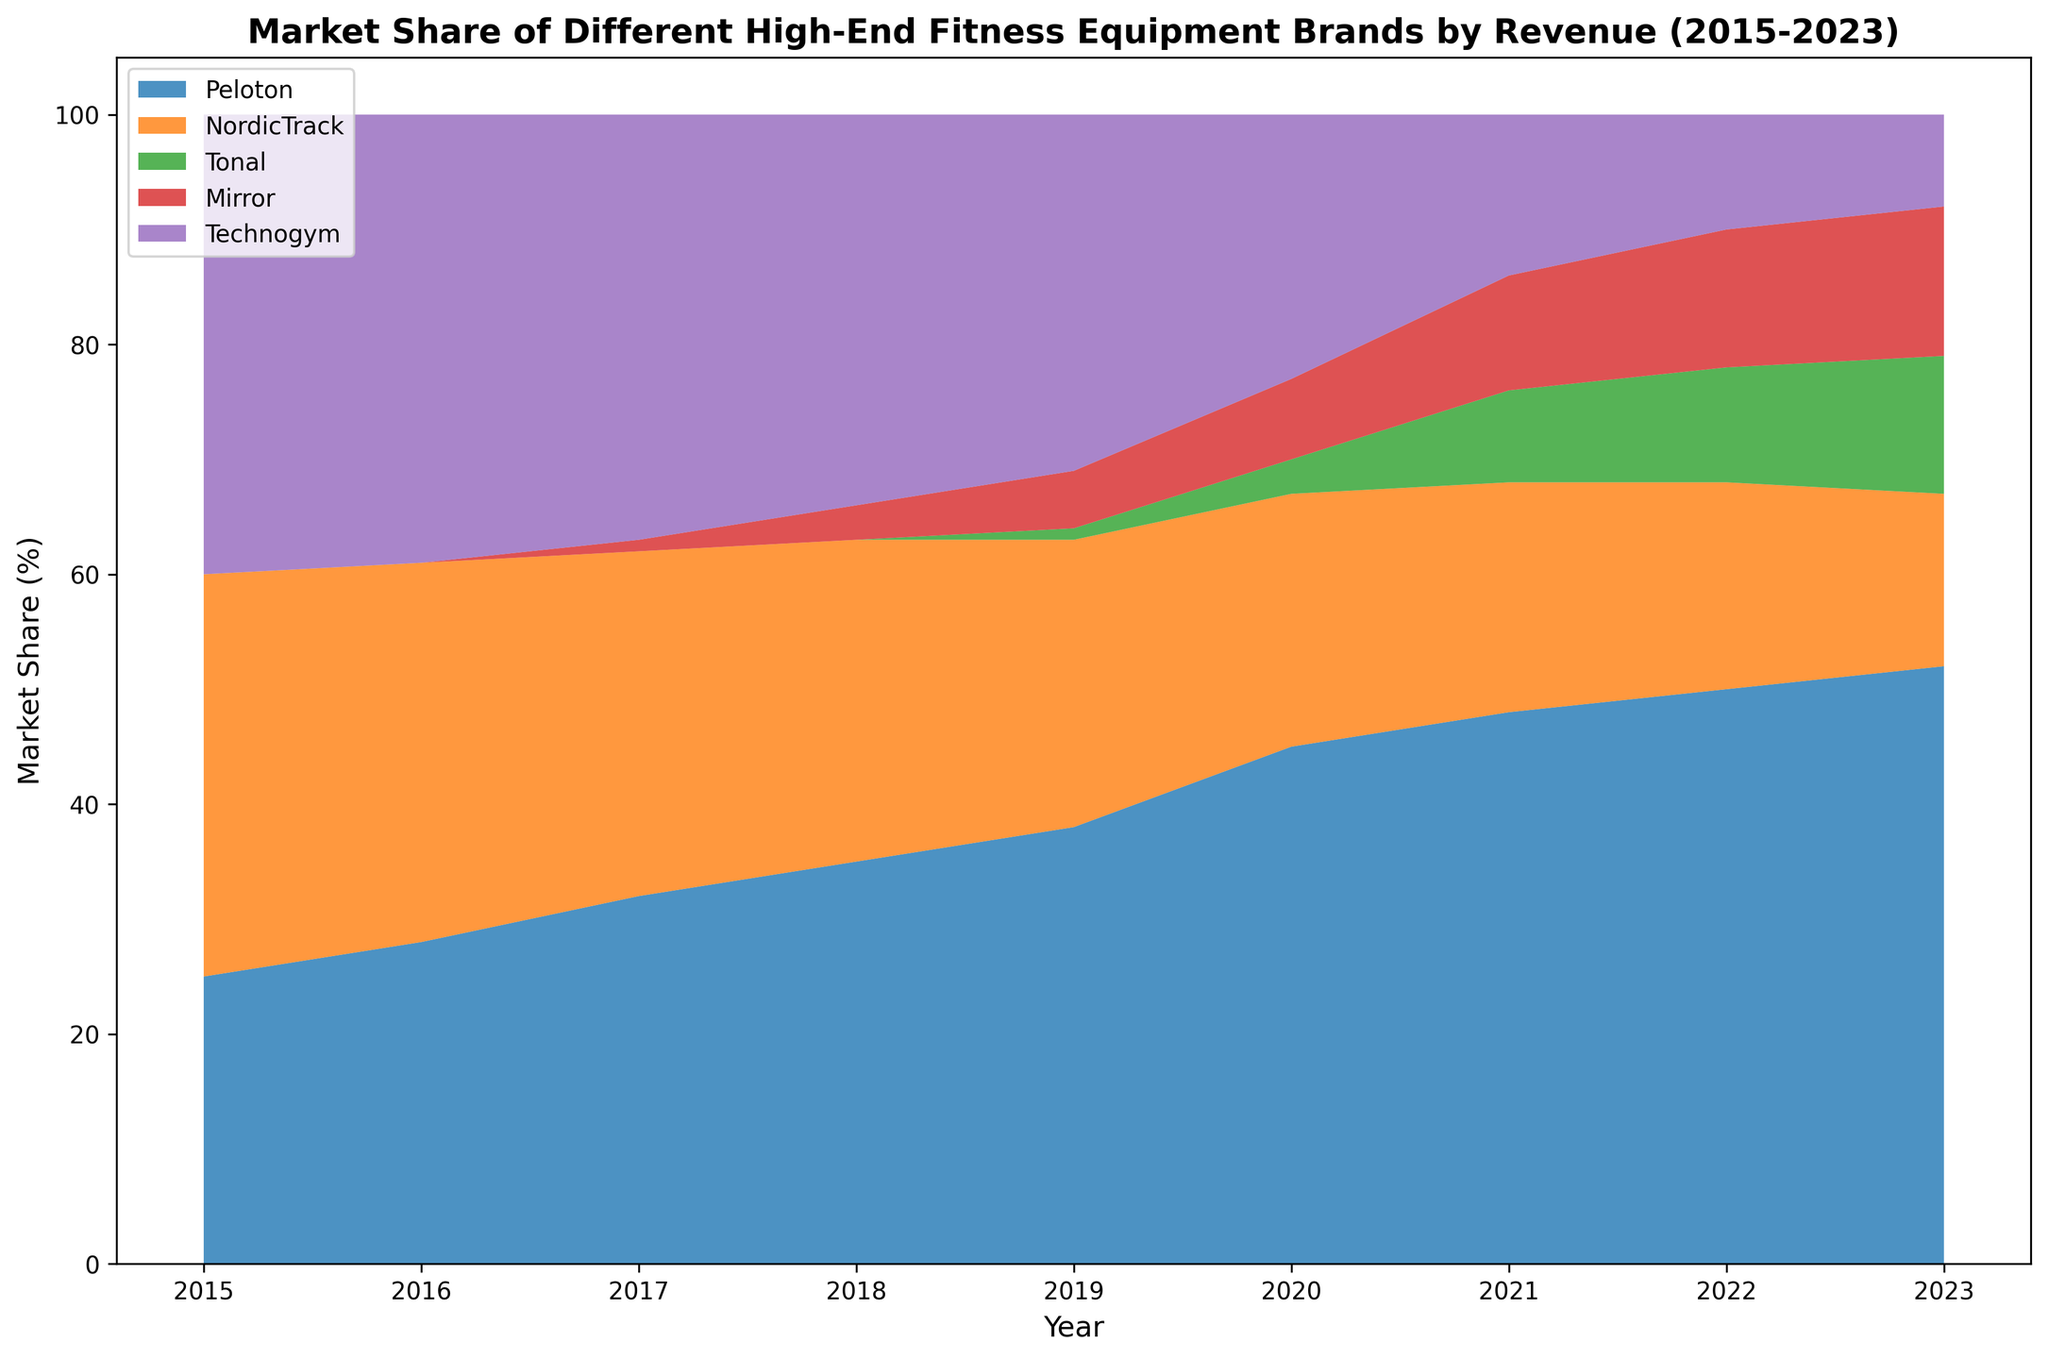Which brand had the largest market share in 2023? To determine which brand had the largest market share in 2023, look at the topmost area in the stacked area chart for 2023. The Peloton area is at the top.
Answer: Peloton How has the market share of Technogym changed between 2015 and 2023? To see how Technogym's market share has changed, observe the size of the Technogym area from 2015 to 2023. The area decreases consistently over the years.
Answer: Decreased By how much did Peloton's market share increase from 2015 to 2023? To calculate the increase, subtract Peloton's market share in 2015 from its share in 2023. The shares are 25% in 2015 and 52% in 2023, so the increase is 52 - 25.
Answer: 27% Which two brands had the closest market shares in 2023, and what were their shares? To determine which brands had the closest market shares, compare the sizes of the areas in 2023. Tonal and Mirror had shares of 12% and 13%, respectively, which are close to each other.
Answer: Tonal and Mirror, 12% and 13% What is the average market share of NordicTrack from 2015 to 2023? To find the average, sum the market share values for NordicTrack from 2015 to 2023 and divide by the number of years. The sums are (35 + 33 + 30 + 28 + 25 + 22 + 20 + 18 + 15) = 226. 226 / 9 = 25.1.
Answer: 25.1% Which year saw the introduction of Tonal into the market, and what was its market share that year? To identify the year Tonal was introduced, look for the first year that Tonal's area appears in the chart. Tonal appears in 2019 with a market share of 1%.
Answer: 2019, 1% Compare the market shares of Peloton and Technogym in 2020. Which was higher and by how much? To compare, subtract Technogym's market share from Peloton's in 2020. Peloton had 45%, and Technogym had 23%. 45 - 23 = 22.
Answer: Peloton, 22% What was the combined market share of Mirror and Tonal in 2023? To find the combined market share of Mirror and Tonal in 2023, add their market shares. Mirror has 13% and Tonal has 12%, so 13 + 12 = 25%.
Answer: 25% Identify a period where one brand had a declining market share while another brand had an increasing market share. To identify the period, observe the chart for overlapping areas where one area gets smaller while another gets larger. From 2015 to 2020, Technogym's share declines while Peloton's share increases.
Answer: 2015 to 2020, Peloton increases, Technogym decreases 